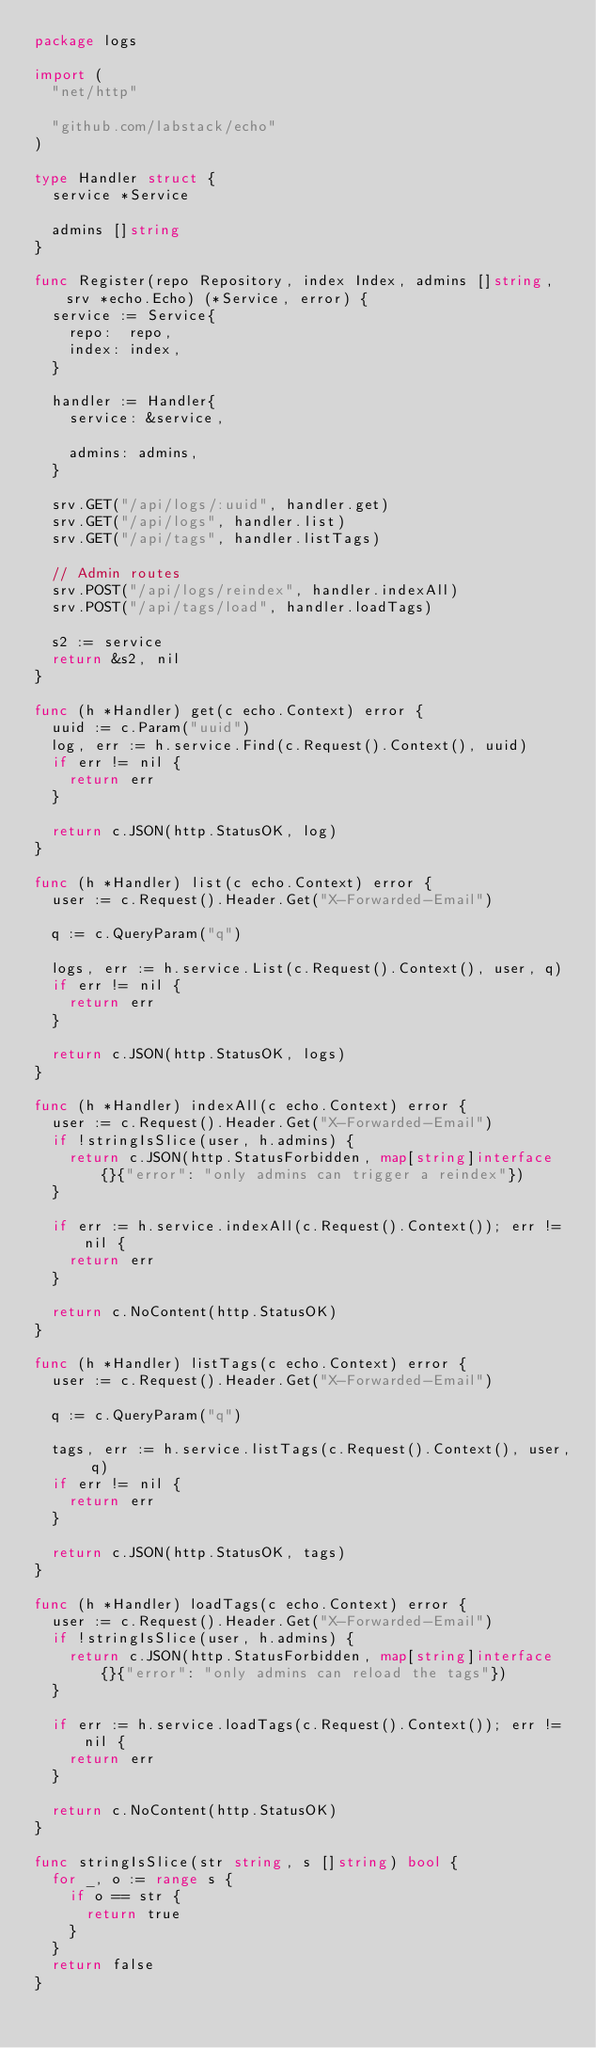<code> <loc_0><loc_0><loc_500><loc_500><_Go_>package logs

import (
	"net/http"

	"github.com/labstack/echo"
)

type Handler struct {
	service *Service

	admins []string
}

func Register(repo Repository, index Index, admins []string, srv *echo.Echo) (*Service, error) {
	service := Service{
		repo:  repo,
		index: index,
	}

	handler := Handler{
		service: &service,

		admins: admins,
	}

	srv.GET("/api/logs/:uuid", handler.get)
	srv.GET("/api/logs", handler.list)
	srv.GET("/api/tags", handler.listTags)

	// Admin routes
	srv.POST("/api/logs/reindex", handler.indexAll)
	srv.POST("/api/tags/load", handler.loadTags)

	s2 := service
	return &s2, nil
}

func (h *Handler) get(c echo.Context) error {
	uuid := c.Param("uuid")
	log, err := h.service.Find(c.Request().Context(), uuid)
	if err != nil {
		return err
	}

	return c.JSON(http.StatusOK, log)
}

func (h *Handler) list(c echo.Context) error {
	user := c.Request().Header.Get("X-Forwarded-Email")

	q := c.QueryParam("q")

	logs, err := h.service.List(c.Request().Context(), user, q)
	if err != nil {
		return err
	}

	return c.JSON(http.StatusOK, logs)
}

func (h *Handler) indexAll(c echo.Context) error {
	user := c.Request().Header.Get("X-Forwarded-Email")
	if !stringIsSlice(user, h.admins) {
		return c.JSON(http.StatusForbidden, map[string]interface{}{"error": "only admins can trigger a reindex"})
	}

	if err := h.service.indexAll(c.Request().Context()); err != nil {
		return err
	}

	return c.NoContent(http.StatusOK)
}

func (h *Handler) listTags(c echo.Context) error {
	user := c.Request().Header.Get("X-Forwarded-Email")

	q := c.QueryParam("q")

	tags, err := h.service.listTags(c.Request().Context(), user, q)
	if err != nil {
		return err
	}

	return c.JSON(http.StatusOK, tags)
}

func (h *Handler) loadTags(c echo.Context) error {
	user := c.Request().Header.Get("X-Forwarded-Email")
	if !stringIsSlice(user, h.admins) {
		return c.JSON(http.StatusForbidden, map[string]interface{}{"error": "only admins can reload the tags"})
	}

	if err := h.service.loadTags(c.Request().Context()); err != nil {
		return err
	}

	return c.NoContent(http.StatusOK)
}

func stringIsSlice(str string, s []string) bool {
	for _, o := range s {
		if o == str {
			return true
		}
	}
	return false
}
</code> 